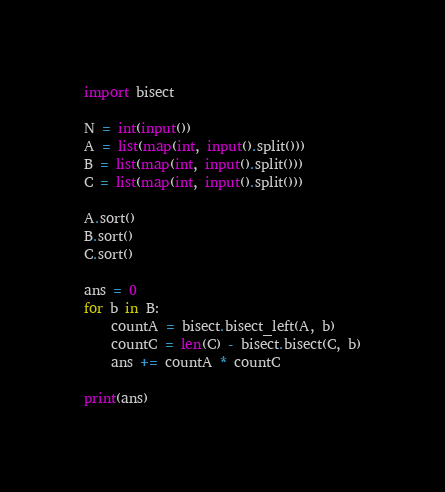Convert code to text. <code><loc_0><loc_0><loc_500><loc_500><_Python_>import bisect

N = int(input())
A = list(map(int, input().split()))
B = list(map(int, input().split()))
C = list(map(int, input().split()))

A.sort()
B.sort()
C.sort()

ans = 0
for b in B:
    countA = bisect.bisect_left(A, b)
    countC = len(C) - bisect.bisect(C, b)
    ans += countA * countC

print(ans)
</code> 